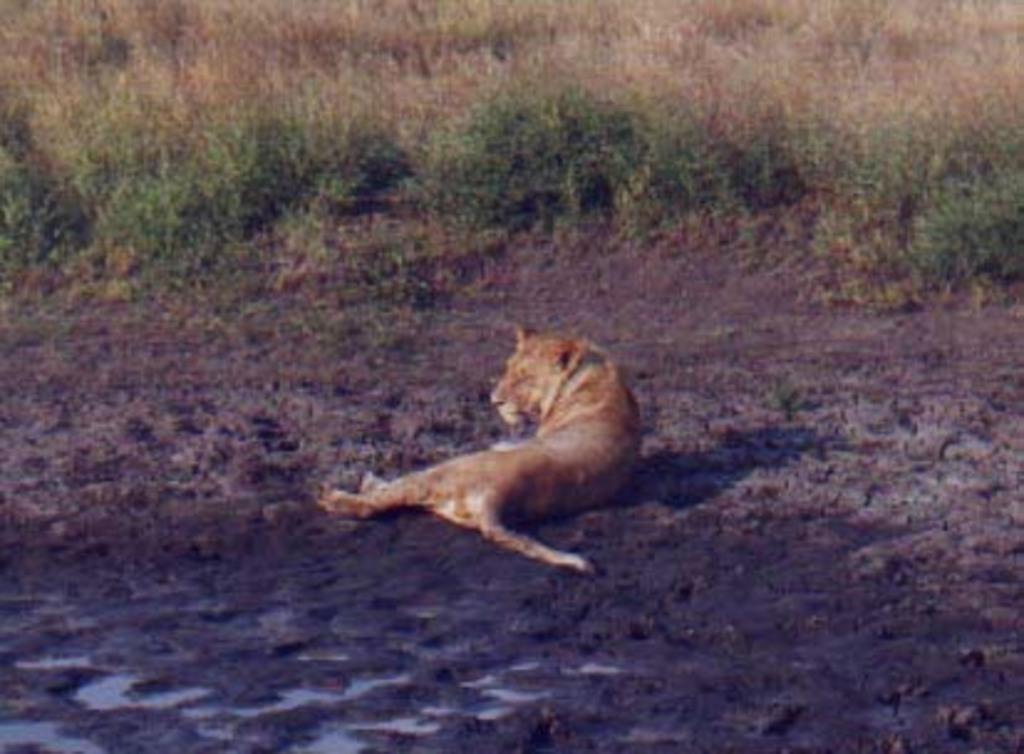How would you summarize this image in a sentence or two? In the middle of the picture I can see a tiger. In the background, I can see grass and plants. 